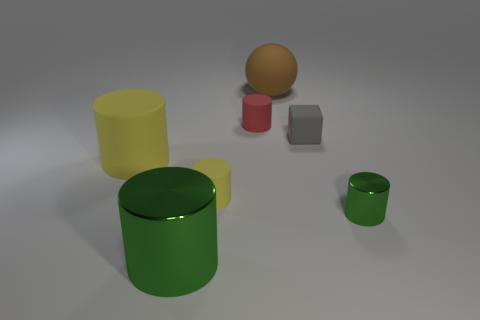What colors are the objects in the image, and how are they positioned relative to each other? In the image, there are objects with colors yellow, red, gray, green, and a shade of orange-brown. Starting from the foreground, there is a large green cylinder, followed by a small yellow cylinder to its left, and a tiny red cylinder close to the latter. On the right side of the green cylinder but further back, there is a medium gray cube and to its right, an orange-brown sphere floating slightly above the surface. 